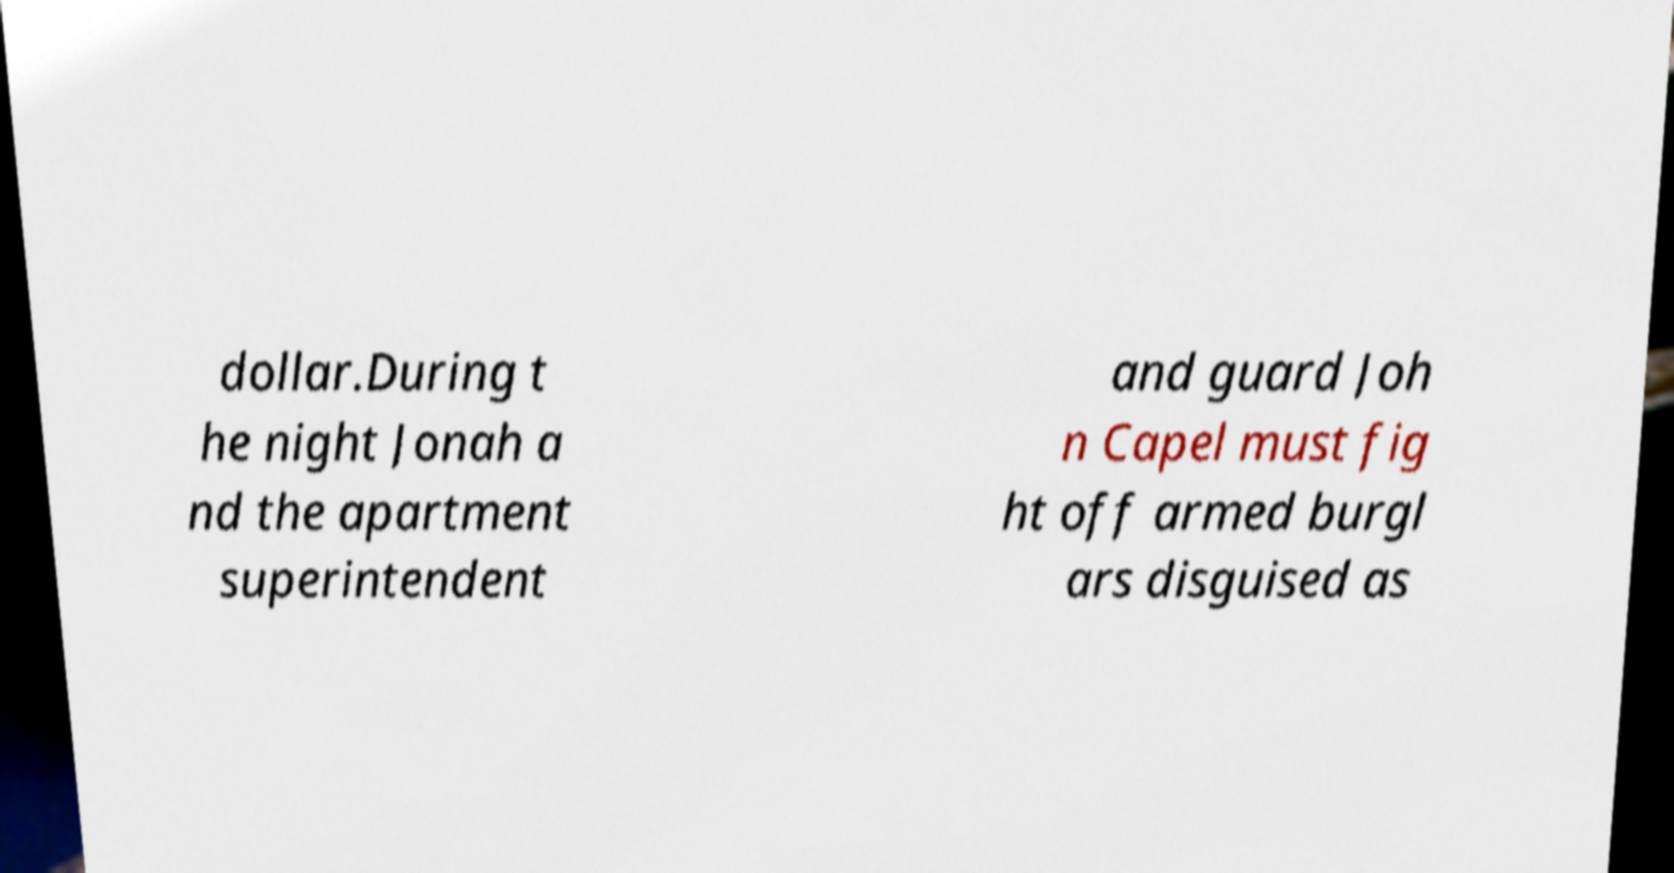Could you assist in decoding the text presented in this image and type it out clearly? dollar.During t he night Jonah a nd the apartment superintendent and guard Joh n Capel must fig ht off armed burgl ars disguised as 